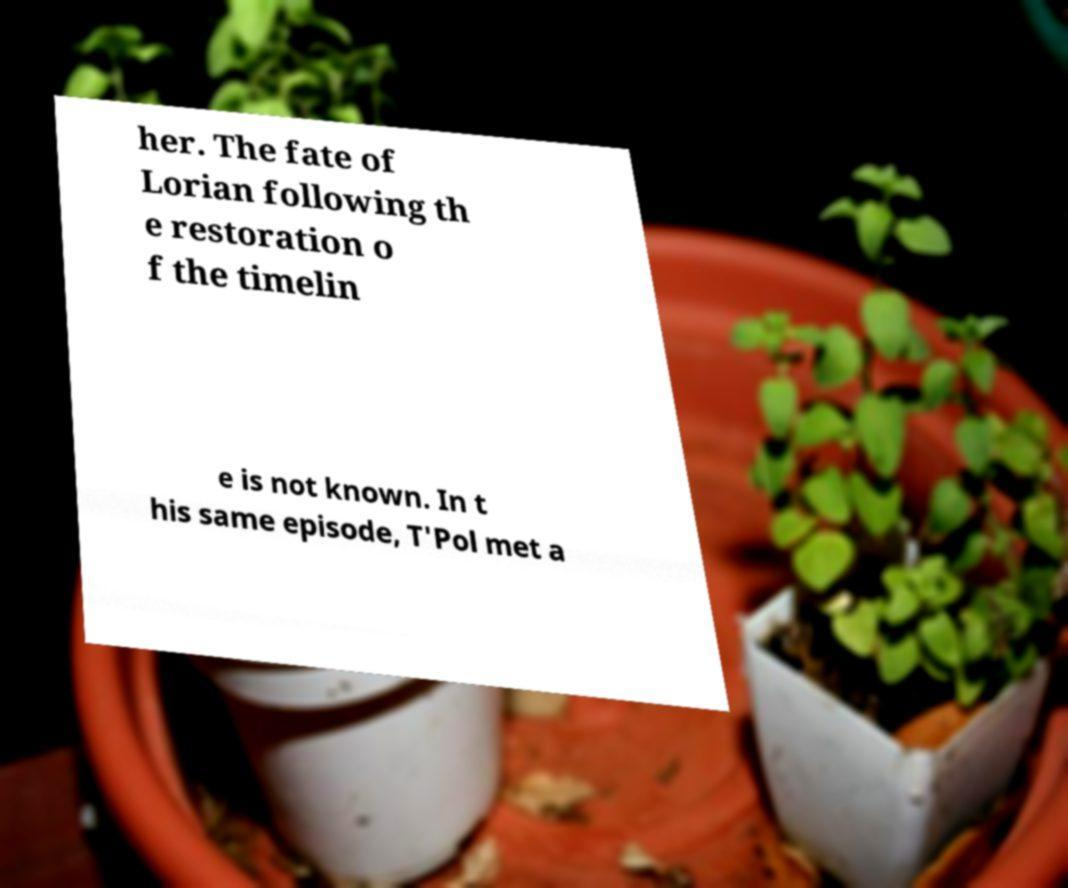I need the written content from this picture converted into text. Can you do that? her. The fate of Lorian following th e restoration o f the timelin e is not known. In t his same episode, T'Pol met a 